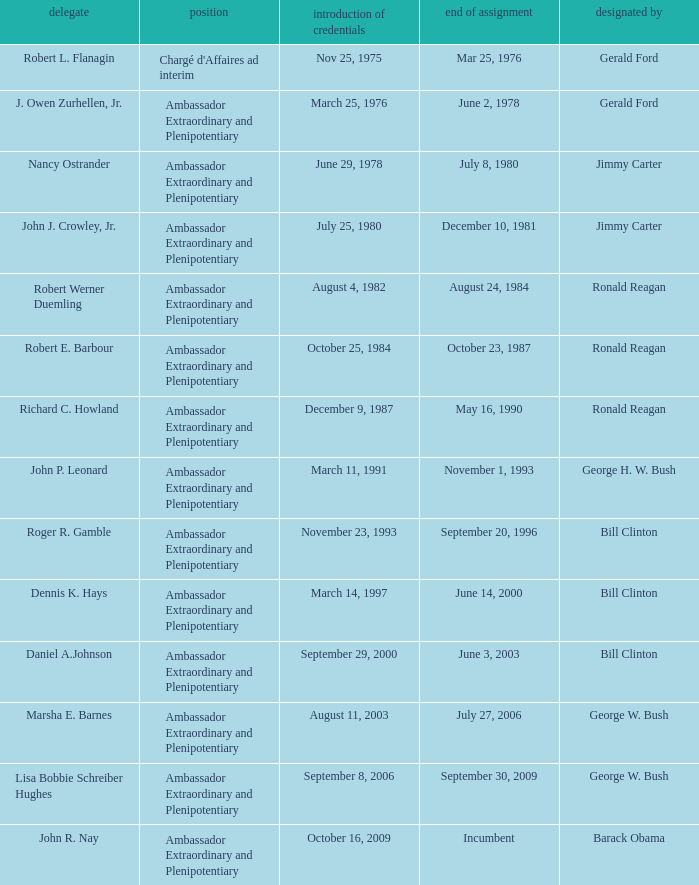Who appointed the representative that had a Presentation of Credentials on March 25, 1976? Gerald Ford. 